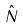<formula> <loc_0><loc_0><loc_500><loc_500>\hat { N }</formula> 